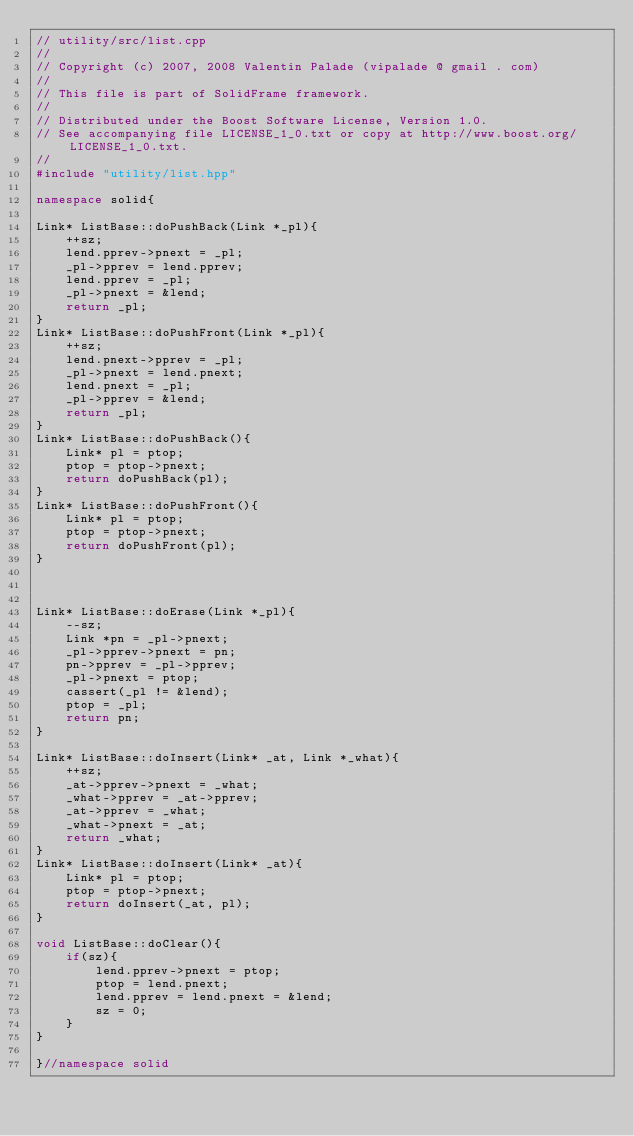Convert code to text. <code><loc_0><loc_0><loc_500><loc_500><_C++_>// utility/src/list.cpp
//
// Copyright (c) 2007, 2008 Valentin Palade (vipalade @ gmail . com) 
//
// This file is part of SolidFrame framework.
//
// Distributed under the Boost Software License, Version 1.0.
// See accompanying file LICENSE_1_0.txt or copy at http://www.boost.org/LICENSE_1_0.txt.
//
#include "utility/list.hpp"

namespace solid{

Link* ListBase::doPushBack(Link *_pl){
	++sz;
	lend.pprev->pnext = _pl;
	_pl->pprev = lend.pprev;
	lend.pprev = _pl;
	_pl->pnext = &lend;
	return _pl;
}
Link* ListBase::doPushFront(Link *_pl){
	++sz;
	lend.pnext->pprev = _pl;
	_pl->pnext = lend.pnext;
	lend.pnext = _pl;
	_pl->pprev = &lend;
	return _pl;
}
Link* ListBase::doPushBack(){
	Link* pl = ptop;
	ptop = ptop->pnext;
	return doPushBack(pl);
}
Link* ListBase::doPushFront(){
	Link* pl = ptop;
	ptop = ptop->pnext;
	return doPushFront(pl);
}



Link* ListBase::doErase(Link *_pl){
	--sz;
	Link *pn = _pl->pnext;
	_pl->pprev->pnext = pn;
	pn->pprev = _pl->pprev;
	_pl->pnext = ptop;
	cassert(_pl != &lend);
	ptop = _pl;
	return pn;
}

Link* ListBase::doInsert(Link* _at, Link *_what){
	++sz;
	_at->pprev->pnext = _what;
	_what->pprev = _at->pprev;
	_at->pprev = _what;
	_what->pnext = _at;
	return _what;
}
Link* ListBase::doInsert(Link* _at){
	Link* pl = ptop;
	ptop = ptop->pnext;
	return doInsert(_at, pl);
}

void ListBase::doClear(){
	if(sz){
		lend.pprev->pnext = ptop;
		ptop = lend.pnext;
		lend.pprev = lend.pnext = &lend;
		sz = 0;
	}
}

}//namespace solid
</code> 